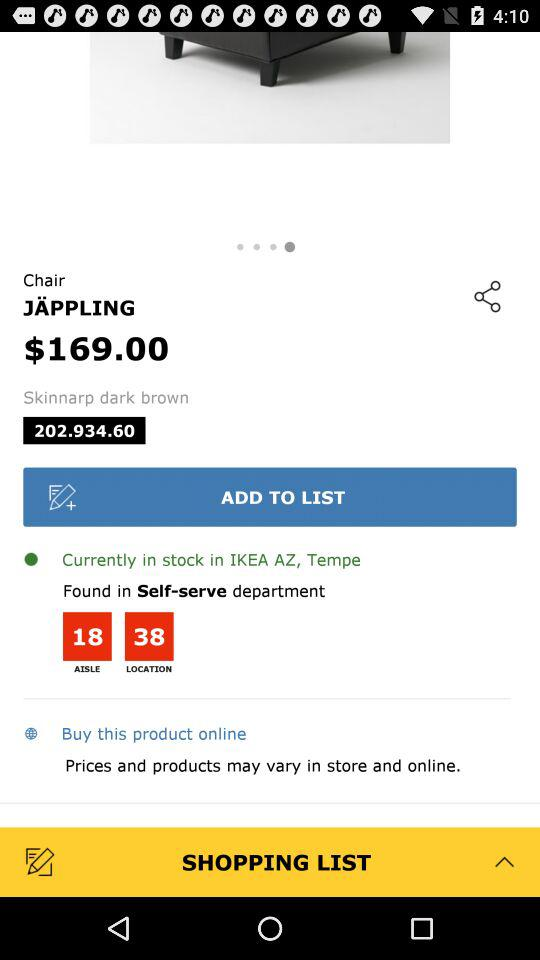What is the aisle number for the product?
Answer the question using a single word or phrase. 18 